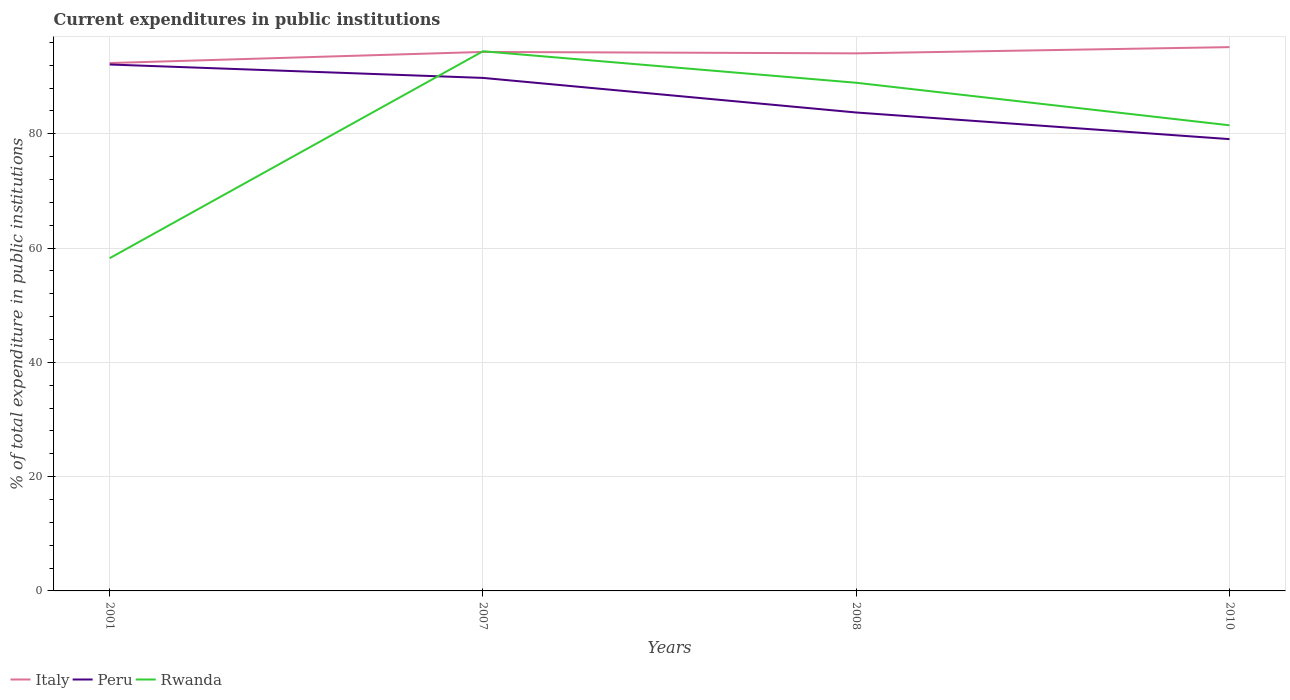How many different coloured lines are there?
Give a very brief answer. 3. Does the line corresponding to Rwanda intersect with the line corresponding to Peru?
Provide a succinct answer. Yes. Across all years, what is the maximum current expenditures in public institutions in Italy?
Offer a terse response. 92.39. In which year was the current expenditures in public institutions in Rwanda maximum?
Your answer should be compact. 2001. What is the total current expenditures in public institutions in Peru in the graph?
Provide a succinct answer. 6.05. What is the difference between the highest and the second highest current expenditures in public institutions in Italy?
Offer a terse response. 2.79. What is the difference between the highest and the lowest current expenditures in public institutions in Peru?
Provide a short and direct response. 2. Is the current expenditures in public institutions in Rwanda strictly greater than the current expenditures in public institutions in Peru over the years?
Your answer should be compact. No. How many lines are there?
Give a very brief answer. 3. How many years are there in the graph?
Provide a succinct answer. 4. Does the graph contain grids?
Your answer should be very brief. Yes. What is the title of the graph?
Your answer should be very brief. Current expenditures in public institutions. What is the label or title of the Y-axis?
Offer a terse response. % of total expenditure in public institutions. What is the % of total expenditure in public institutions in Italy in 2001?
Your answer should be very brief. 92.39. What is the % of total expenditure in public institutions in Peru in 2001?
Keep it short and to the point. 92.14. What is the % of total expenditure in public institutions of Rwanda in 2001?
Offer a terse response. 58.24. What is the % of total expenditure in public institutions of Italy in 2007?
Make the answer very short. 94.34. What is the % of total expenditure in public institutions of Peru in 2007?
Give a very brief answer. 89.79. What is the % of total expenditure in public institutions of Rwanda in 2007?
Your answer should be compact. 94.45. What is the % of total expenditure in public institutions of Italy in 2008?
Give a very brief answer. 94.09. What is the % of total expenditure in public institutions of Peru in 2008?
Ensure brevity in your answer.  83.74. What is the % of total expenditure in public institutions of Rwanda in 2008?
Offer a terse response. 88.94. What is the % of total expenditure in public institutions in Italy in 2010?
Give a very brief answer. 95.18. What is the % of total expenditure in public institutions of Peru in 2010?
Ensure brevity in your answer.  79.08. What is the % of total expenditure in public institutions of Rwanda in 2010?
Keep it short and to the point. 81.5. Across all years, what is the maximum % of total expenditure in public institutions in Italy?
Your answer should be compact. 95.18. Across all years, what is the maximum % of total expenditure in public institutions of Peru?
Give a very brief answer. 92.14. Across all years, what is the maximum % of total expenditure in public institutions of Rwanda?
Provide a succinct answer. 94.45. Across all years, what is the minimum % of total expenditure in public institutions of Italy?
Make the answer very short. 92.39. Across all years, what is the minimum % of total expenditure in public institutions of Peru?
Make the answer very short. 79.08. Across all years, what is the minimum % of total expenditure in public institutions of Rwanda?
Give a very brief answer. 58.24. What is the total % of total expenditure in public institutions in Italy in the graph?
Keep it short and to the point. 376. What is the total % of total expenditure in public institutions in Peru in the graph?
Your answer should be very brief. 344.74. What is the total % of total expenditure in public institutions of Rwanda in the graph?
Your answer should be compact. 323.13. What is the difference between the % of total expenditure in public institutions of Italy in 2001 and that in 2007?
Provide a succinct answer. -1.94. What is the difference between the % of total expenditure in public institutions in Peru in 2001 and that in 2007?
Make the answer very short. 2.35. What is the difference between the % of total expenditure in public institutions of Rwanda in 2001 and that in 2007?
Provide a succinct answer. -36.22. What is the difference between the % of total expenditure in public institutions in Italy in 2001 and that in 2008?
Your response must be concise. -1.7. What is the difference between the % of total expenditure in public institutions in Peru in 2001 and that in 2008?
Your response must be concise. 8.4. What is the difference between the % of total expenditure in public institutions of Rwanda in 2001 and that in 2008?
Your answer should be very brief. -30.7. What is the difference between the % of total expenditure in public institutions of Italy in 2001 and that in 2010?
Your answer should be compact. -2.79. What is the difference between the % of total expenditure in public institutions of Peru in 2001 and that in 2010?
Your answer should be very brief. 13.06. What is the difference between the % of total expenditure in public institutions of Rwanda in 2001 and that in 2010?
Make the answer very short. -23.26. What is the difference between the % of total expenditure in public institutions of Italy in 2007 and that in 2008?
Provide a succinct answer. 0.25. What is the difference between the % of total expenditure in public institutions in Peru in 2007 and that in 2008?
Your answer should be very brief. 6.05. What is the difference between the % of total expenditure in public institutions of Rwanda in 2007 and that in 2008?
Your answer should be very brief. 5.51. What is the difference between the % of total expenditure in public institutions of Italy in 2007 and that in 2010?
Provide a short and direct response. -0.84. What is the difference between the % of total expenditure in public institutions of Peru in 2007 and that in 2010?
Your answer should be very brief. 10.71. What is the difference between the % of total expenditure in public institutions of Rwanda in 2007 and that in 2010?
Offer a terse response. 12.96. What is the difference between the % of total expenditure in public institutions of Italy in 2008 and that in 2010?
Provide a short and direct response. -1.09. What is the difference between the % of total expenditure in public institutions of Peru in 2008 and that in 2010?
Your answer should be very brief. 4.66. What is the difference between the % of total expenditure in public institutions in Rwanda in 2008 and that in 2010?
Provide a short and direct response. 7.44. What is the difference between the % of total expenditure in public institutions of Italy in 2001 and the % of total expenditure in public institutions of Peru in 2007?
Ensure brevity in your answer.  2.6. What is the difference between the % of total expenditure in public institutions of Italy in 2001 and the % of total expenditure in public institutions of Rwanda in 2007?
Make the answer very short. -2.06. What is the difference between the % of total expenditure in public institutions of Peru in 2001 and the % of total expenditure in public institutions of Rwanda in 2007?
Give a very brief answer. -2.32. What is the difference between the % of total expenditure in public institutions of Italy in 2001 and the % of total expenditure in public institutions of Peru in 2008?
Ensure brevity in your answer.  8.65. What is the difference between the % of total expenditure in public institutions of Italy in 2001 and the % of total expenditure in public institutions of Rwanda in 2008?
Ensure brevity in your answer.  3.45. What is the difference between the % of total expenditure in public institutions in Peru in 2001 and the % of total expenditure in public institutions in Rwanda in 2008?
Make the answer very short. 3.2. What is the difference between the % of total expenditure in public institutions in Italy in 2001 and the % of total expenditure in public institutions in Peru in 2010?
Your answer should be compact. 13.31. What is the difference between the % of total expenditure in public institutions in Italy in 2001 and the % of total expenditure in public institutions in Rwanda in 2010?
Ensure brevity in your answer.  10.89. What is the difference between the % of total expenditure in public institutions in Peru in 2001 and the % of total expenditure in public institutions in Rwanda in 2010?
Provide a succinct answer. 10.64. What is the difference between the % of total expenditure in public institutions of Italy in 2007 and the % of total expenditure in public institutions of Peru in 2008?
Your answer should be very brief. 10.6. What is the difference between the % of total expenditure in public institutions in Italy in 2007 and the % of total expenditure in public institutions in Rwanda in 2008?
Offer a very short reply. 5.39. What is the difference between the % of total expenditure in public institutions of Peru in 2007 and the % of total expenditure in public institutions of Rwanda in 2008?
Your response must be concise. 0.85. What is the difference between the % of total expenditure in public institutions of Italy in 2007 and the % of total expenditure in public institutions of Peru in 2010?
Give a very brief answer. 15.26. What is the difference between the % of total expenditure in public institutions of Italy in 2007 and the % of total expenditure in public institutions of Rwanda in 2010?
Keep it short and to the point. 12.84. What is the difference between the % of total expenditure in public institutions in Peru in 2007 and the % of total expenditure in public institutions in Rwanda in 2010?
Offer a very short reply. 8.29. What is the difference between the % of total expenditure in public institutions of Italy in 2008 and the % of total expenditure in public institutions of Peru in 2010?
Ensure brevity in your answer.  15.01. What is the difference between the % of total expenditure in public institutions of Italy in 2008 and the % of total expenditure in public institutions of Rwanda in 2010?
Keep it short and to the point. 12.59. What is the difference between the % of total expenditure in public institutions in Peru in 2008 and the % of total expenditure in public institutions in Rwanda in 2010?
Keep it short and to the point. 2.24. What is the average % of total expenditure in public institutions of Italy per year?
Your answer should be very brief. 94. What is the average % of total expenditure in public institutions of Peru per year?
Offer a terse response. 86.19. What is the average % of total expenditure in public institutions in Rwanda per year?
Offer a very short reply. 80.78. In the year 2001, what is the difference between the % of total expenditure in public institutions of Italy and % of total expenditure in public institutions of Peru?
Provide a short and direct response. 0.25. In the year 2001, what is the difference between the % of total expenditure in public institutions in Italy and % of total expenditure in public institutions in Rwanda?
Offer a very short reply. 34.15. In the year 2001, what is the difference between the % of total expenditure in public institutions of Peru and % of total expenditure in public institutions of Rwanda?
Provide a short and direct response. 33.9. In the year 2007, what is the difference between the % of total expenditure in public institutions in Italy and % of total expenditure in public institutions in Peru?
Ensure brevity in your answer.  4.55. In the year 2007, what is the difference between the % of total expenditure in public institutions of Italy and % of total expenditure in public institutions of Rwanda?
Your answer should be compact. -0.12. In the year 2007, what is the difference between the % of total expenditure in public institutions in Peru and % of total expenditure in public institutions in Rwanda?
Your response must be concise. -4.66. In the year 2008, what is the difference between the % of total expenditure in public institutions of Italy and % of total expenditure in public institutions of Peru?
Provide a succinct answer. 10.35. In the year 2008, what is the difference between the % of total expenditure in public institutions in Italy and % of total expenditure in public institutions in Rwanda?
Offer a terse response. 5.15. In the year 2008, what is the difference between the % of total expenditure in public institutions in Peru and % of total expenditure in public institutions in Rwanda?
Give a very brief answer. -5.21. In the year 2010, what is the difference between the % of total expenditure in public institutions in Italy and % of total expenditure in public institutions in Peru?
Your answer should be compact. 16.1. In the year 2010, what is the difference between the % of total expenditure in public institutions of Italy and % of total expenditure in public institutions of Rwanda?
Offer a very short reply. 13.68. In the year 2010, what is the difference between the % of total expenditure in public institutions in Peru and % of total expenditure in public institutions in Rwanda?
Make the answer very short. -2.42. What is the ratio of the % of total expenditure in public institutions in Italy in 2001 to that in 2007?
Keep it short and to the point. 0.98. What is the ratio of the % of total expenditure in public institutions of Peru in 2001 to that in 2007?
Offer a very short reply. 1.03. What is the ratio of the % of total expenditure in public institutions of Rwanda in 2001 to that in 2007?
Give a very brief answer. 0.62. What is the ratio of the % of total expenditure in public institutions of Italy in 2001 to that in 2008?
Ensure brevity in your answer.  0.98. What is the ratio of the % of total expenditure in public institutions of Peru in 2001 to that in 2008?
Your answer should be very brief. 1.1. What is the ratio of the % of total expenditure in public institutions of Rwanda in 2001 to that in 2008?
Your answer should be compact. 0.65. What is the ratio of the % of total expenditure in public institutions in Italy in 2001 to that in 2010?
Your answer should be very brief. 0.97. What is the ratio of the % of total expenditure in public institutions of Peru in 2001 to that in 2010?
Provide a short and direct response. 1.17. What is the ratio of the % of total expenditure in public institutions in Rwanda in 2001 to that in 2010?
Your answer should be compact. 0.71. What is the ratio of the % of total expenditure in public institutions of Italy in 2007 to that in 2008?
Make the answer very short. 1. What is the ratio of the % of total expenditure in public institutions in Peru in 2007 to that in 2008?
Your answer should be compact. 1.07. What is the ratio of the % of total expenditure in public institutions in Rwanda in 2007 to that in 2008?
Offer a very short reply. 1.06. What is the ratio of the % of total expenditure in public institutions in Peru in 2007 to that in 2010?
Your answer should be compact. 1.14. What is the ratio of the % of total expenditure in public institutions in Rwanda in 2007 to that in 2010?
Make the answer very short. 1.16. What is the ratio of the % of total expenditure in public institutions of Peru in 2008 to that in 2010?
Make the answer very short. 1.06. What is the ratio of the % of total expenditure in public institutions in Rwanda in 2008 to that in 2010?
Provide a short and direct response. 1.09. What is the difference between the highest and the second highest % of total expenditure in public institutions of Italy?
Your answer should be very brief. 0.84. What is the difference between the highest and the second highest % of total expenditure in public institutions of Peru?
Offer a terse response. 2.35. What is the difference between the highest and the second highest % of total expenditure in public institutions in Rwanda?
Keep it short and to the point. 5.51. What is the difference between the highest and the lowest % of total expenditure in public institutions in Italy?
Offer a very short reply. 2.79. What is the difference between the highest and the lowest % of total expenditure in public institutions of Peru?
Offer a very short reply. 13.06. What is the difference between the highest and the lowest % of total expenditure in public institutions of Rwanda?
Ensure brevity in your answer.  36.22. 